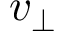Convert formula to latex. <formula><loc_0><loc_0><loc_500><loc_500>v _ { \perp }</formula> 